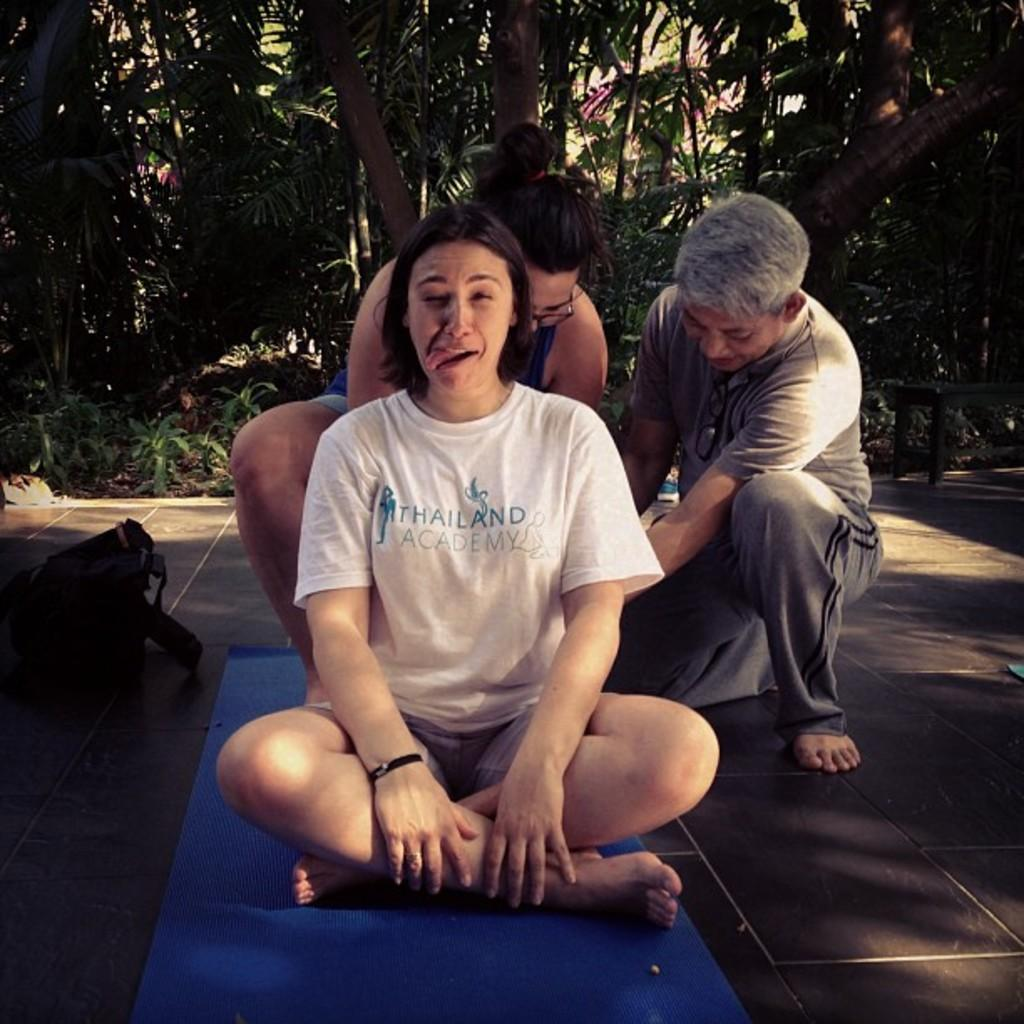How many people are in the image? There are three persons in the image. Where are the persons located? The persons are on the road. What object can be seen in the image besides the people? There is a bag in the image. What can be seen in the background of the image? There are trees and plants in the background of the image. What time of day is the image likely taken? The image is likely taken during the day, as there is sufficient light to see the details. What type of crayon is being used by the persons in the image? There is no crayon present in the image; the persons are on the road, and no such object is visible. 